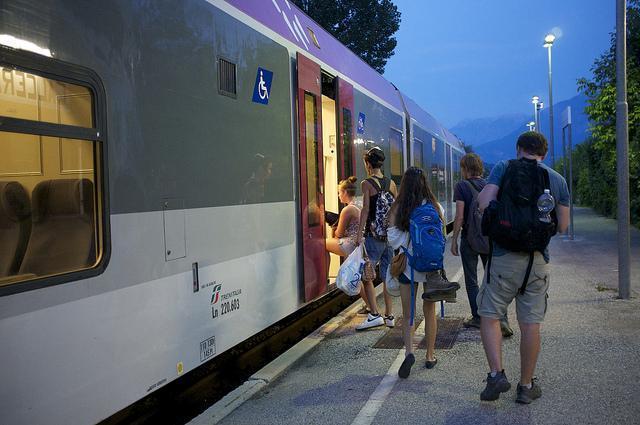How many people are on the train platform?
Give a very brief answer. 5. How many people are on the stairs?
Give a very brief answer. 1. How many people can be seen?
Give a very brief answer. 5. How many backpacks are visible?
Give a very brief answer. 2. How many pick umbrella is there?
Give a very brief answer. 0. 